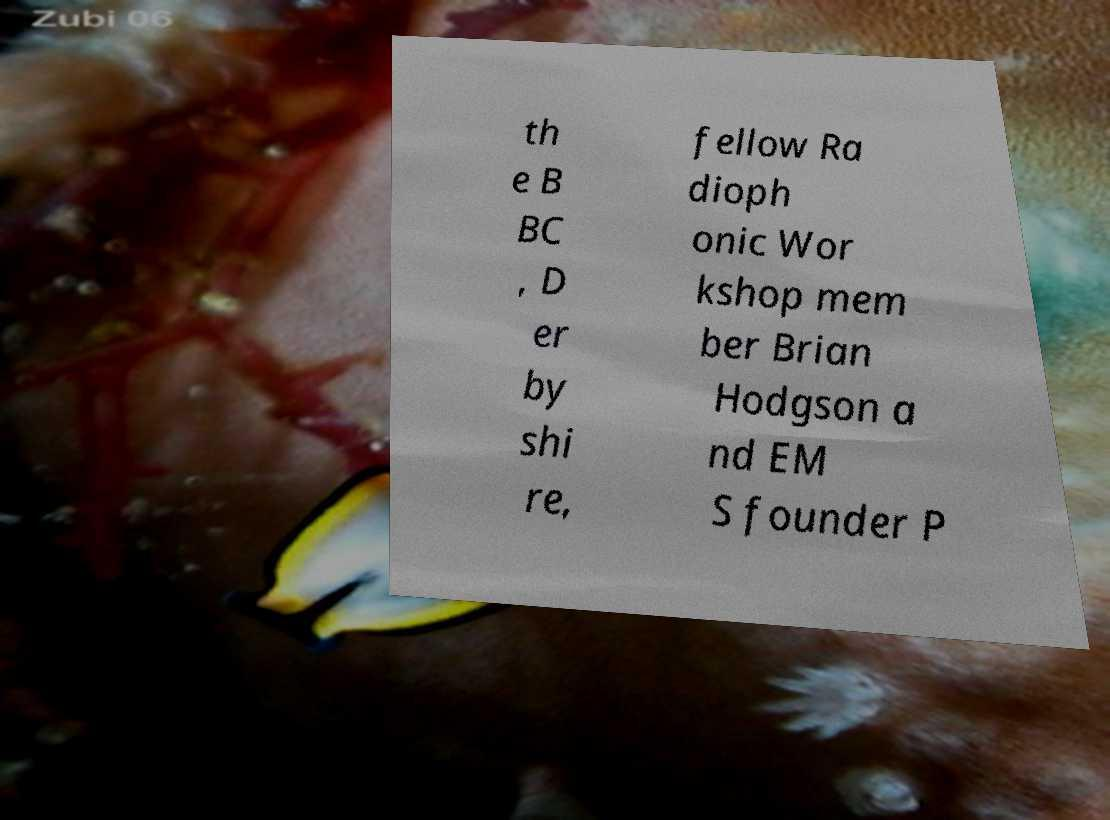For documentation purposes, I need the text within this image transcribed. Could you provide that? th e B BC , D er by shi re, fellow Ra dioph onic Wor kshop mem ber Brian Hodgson a nd EM S founder P 